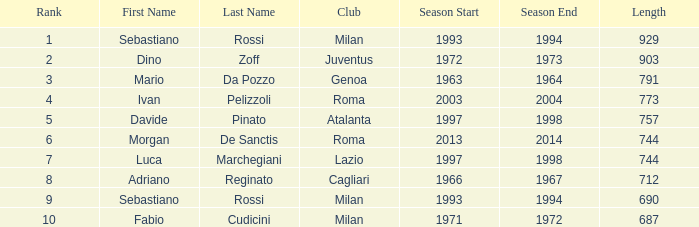What name is associated with a longer length than 903? Sebastiano Rossi. 